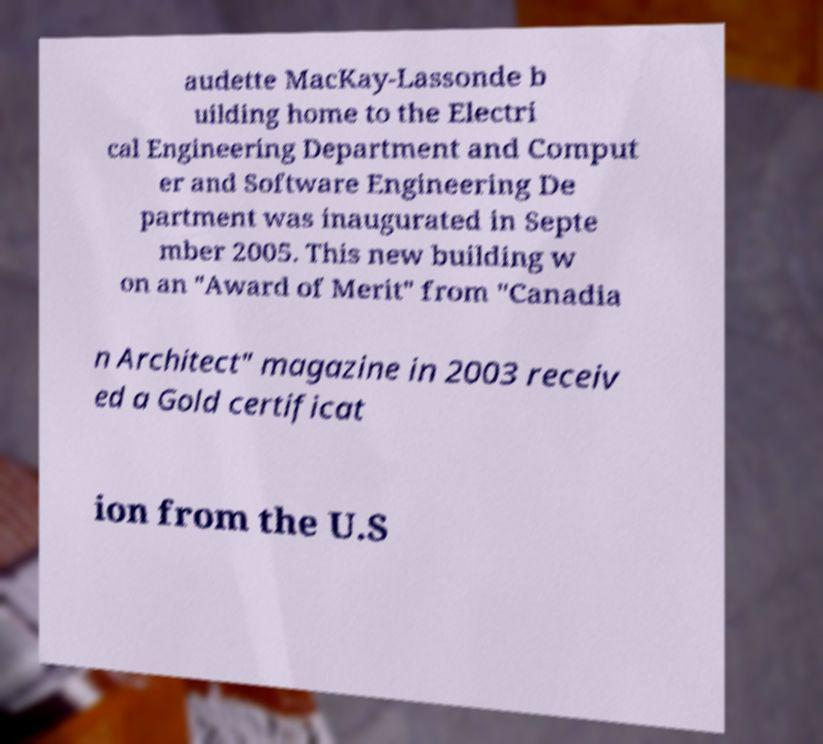What messages or text are displayed in this image? I need them in a readable, typed format. audette MacKay-Lassonde b uilding home to the Electri cal Engineering Department and Comput er and Software Engineering De partment was inaugurated in Septe mber 2005. This new building w on an "Award of Merit" from "Canadia n Architect" magazine in 2003 receiv ed a Gold certificat ion from the U.S 